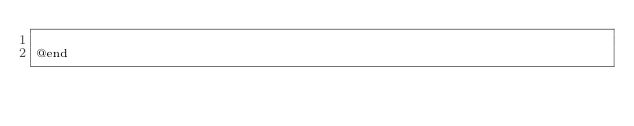<code> <loc_0><loc_0><loc_500><loc_500><_C_>
@end

</code> 